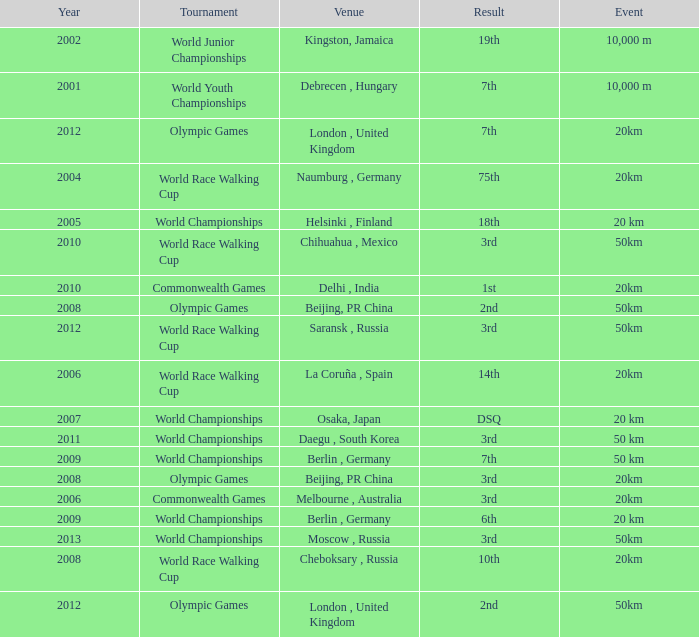What is earliest year that had a 50km event with a 2nd place result played in London, United Kingdom? 2012.0. 